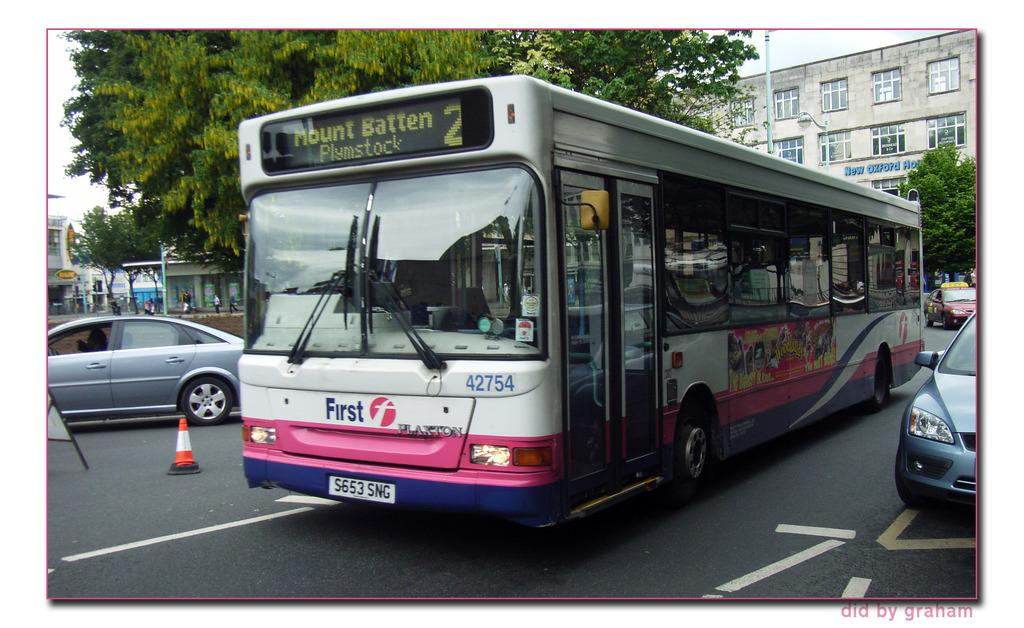What type of vehicles can be seen on the road in the image? There are vehicles on the road in the image, including a bus. What is the specific type of vehicle among the vehicles? A bus is present among the vehicles. What safety feature is placed beside the bus? There is a road divider cone beside the bus. What can be seen in the distance in the image? Buildings, trees, and poles are visible in the background of the image. Are there any people visible in the image? Yes, people are observable in the background of the image. What type of liquid is being served at the airport in the image? There is no airport or liquid being served in the image; it features vehicles on a road with a bus, a road divider cone, and a background with buildings, trees, poles, and people. 